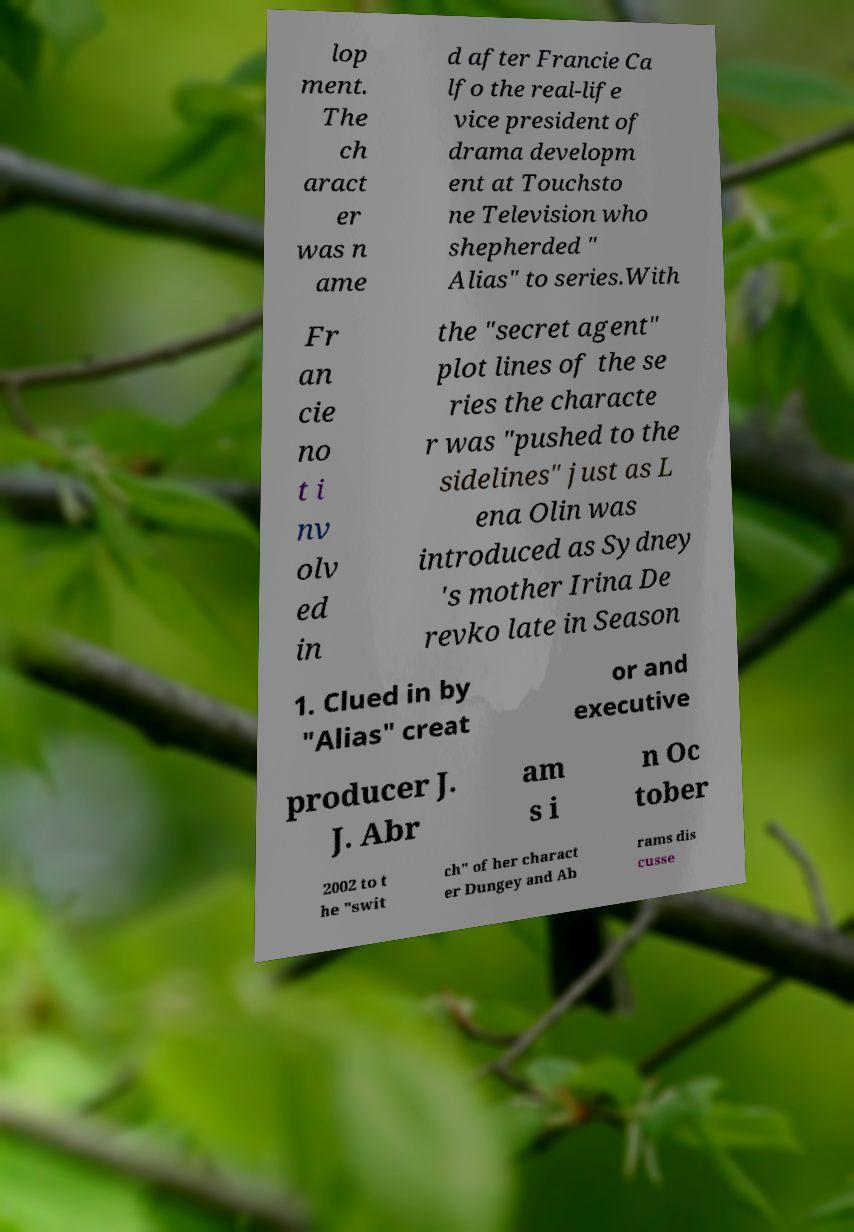Can you accurately transcribe the text from the provided image for me? lop ment. The ch aract er was n ame d after Francie Ca lfo the real-life vice president of drama developm ent at Touchsto ne Television who shepherded " Alias" to series.With Fr an cie no t i nv olv ed in the "secret agent" plot lines of the se ries the characte r was "pushed to the sidelines" just as L ena Olin was introduced as Sydney 's mother Irina De revko late in Season 1. Clued in by "Alias" creat or and executive producer J. J. Abr am s i n Oc tober 2002 to t he "swit ch" of her charact er Dungey and Ab rams dis cusse 